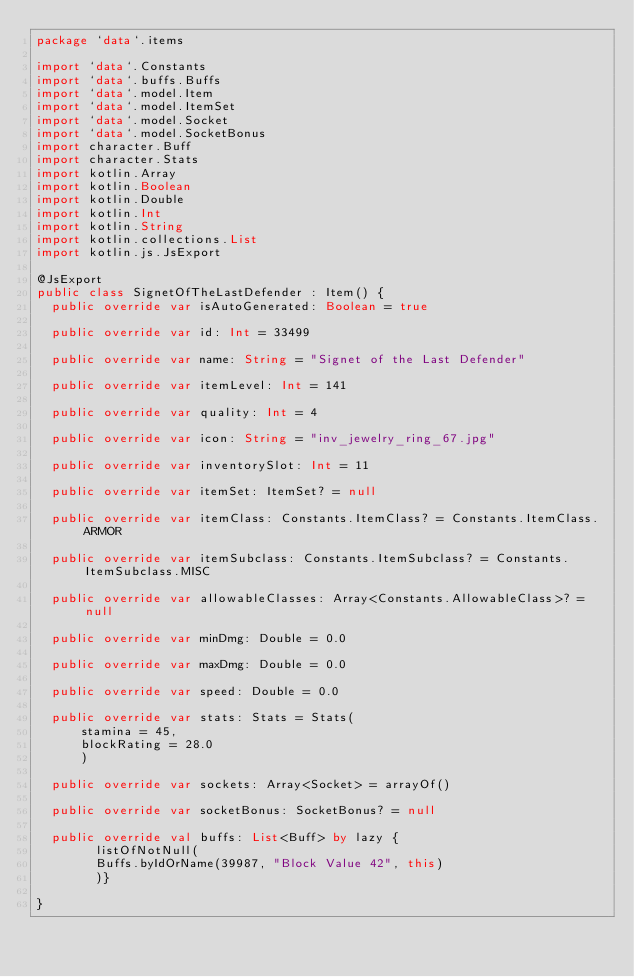Convert code to text. <code><loc_0><loc_0><loc_500><loc_500><_Kotlin_>package `data`.items

import `data`.Constants
import `data`.buffs.Buffs
import `data`.model.Item
import `data`.model.ItemSet
import `data`.model.Socket
import `data`.model.SocketBonus
import character.Buff
import character.Stats
import kotlin.Array
import kotlin.Boolean
import kotlin.Double
import kotlin.Int
import kotlin.String
import kotlin.collections.List
import kotlin.js.JsExport

@JsExport
public class SignetOfTheLastDefender : Item() {
  public override var isAutoGenerated: Boolean = true

  public override var id: Int = 33499

  public override var name: String = "Signet of the Last Defender"

  public override var itemLevel: Int = 141

  public override var quality: Int = 4

  public override var icon: String = "inv_jewelry_ring_67.jpg"

  public override var inventorySlot: Int = 11

  public override var itemSet: ItemSet? = null

  public override var itemClass: Constants.ItemClass? = Constants.ItemClass.ARMOR

  public override var itemSubclass: Constants.ItemSubclass? = Constants.ItemSubclass.MISC

  public override var allowableClasses: Array<Constants.AllowableClass>? = null

  public override var minDmg: Double = 0.0

  public override var maxDmg: Double = 0.0

  public override var speed: Double = 0.0

  public override var stats: Stats = Stats(
      stamina = 45,
      blockRating = 28.0
      )

  public override var sockets: Array<Socket> = arrayOf()

  public override var socketBonus: SocketBonus? = null

  public override val buffs: List<Buff> by lazy {
        listOfNotNull(
        Buffs.byIdOrName(39987, "Block Value 42", this)
        )}

}
</code> 